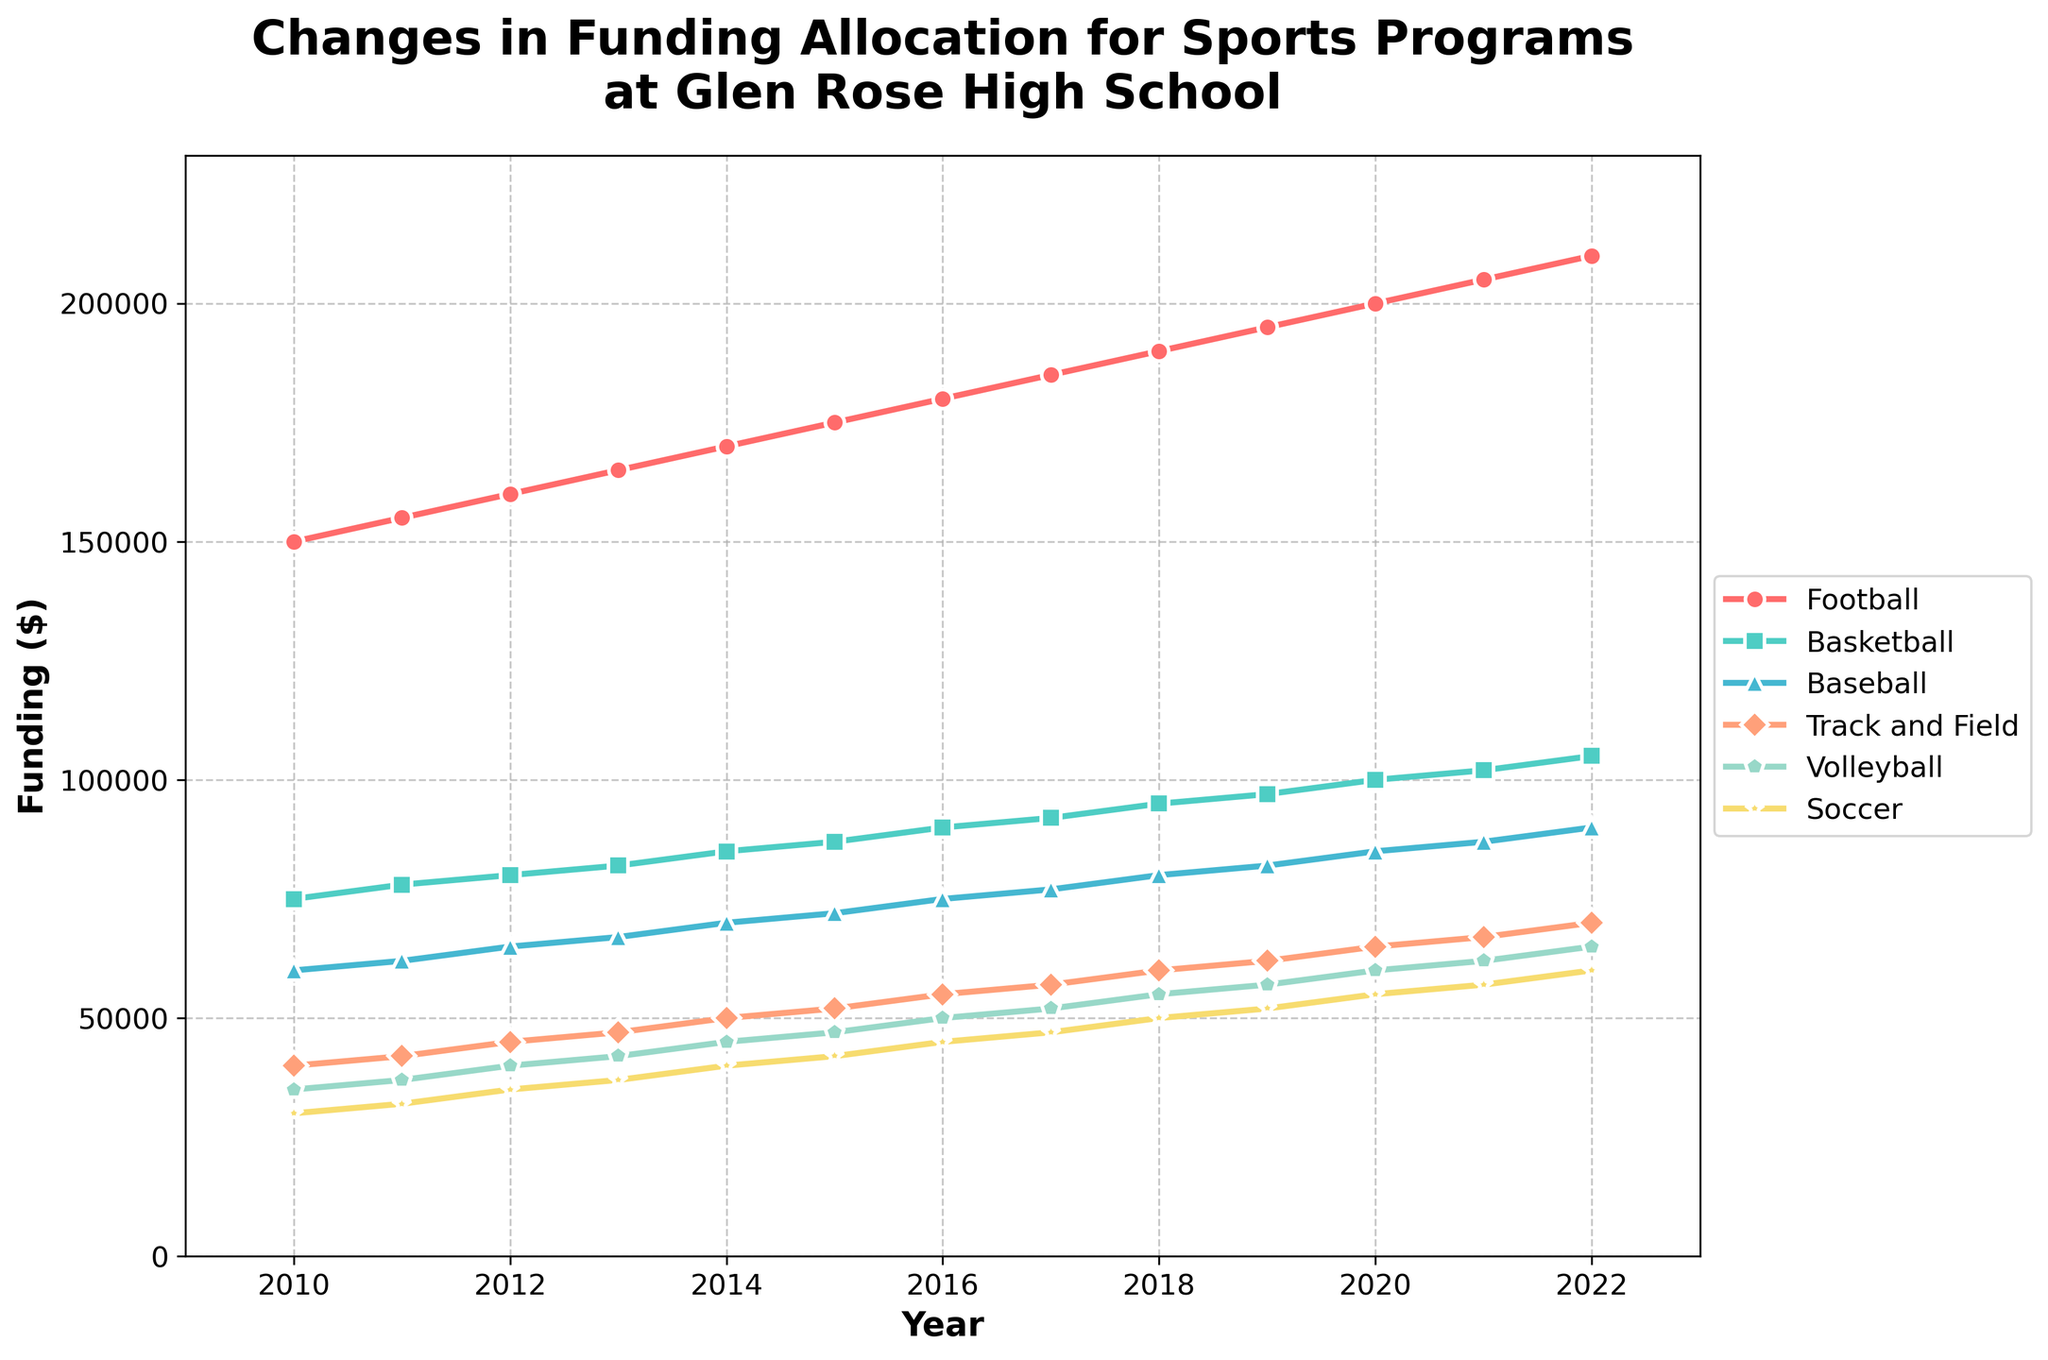How has the funding for the Football program changed from 2010 to 2022? The funding for the Football program in 2010 was $150,000, and it increased to $210,000 in 2022. The difference in funding is $210,000 - $150,000 = $60,000.
Answer: Increased by $60,000 Which sports program experienced the highest percent increase in funding from 2010 to 2022? To find the percent increase, use the formula: \( \frac{\text{New Value} - \text{Old Value}}{\text{Old Value}} \times 100 \). For each sport: 
Football: \( \frac{210000 - 150000}{150000} \times 100 = 40\% \) 
Basketball: \( \frac{105000 - 75000}{75000} \times 100 = 40\% \) 
Baseball: \( \frac{90000 - 60000}{60000} \times 100 = 50\% \) 
Track and Field: \( \frac{70000 - 40000}{40000} \times 100 = 75\% \) 
Volleyball: \( \frac{65000 - 35000}{35000} \times 100 = 85.71\% \) 
Soccer: \( \frac{60000 - 30000}{30000} \times 100 = 100\% \) Soccer experienced the highest percent increase in funding at 100%.
Answer: Soccer In which year did Basketball funding reach $90,000? The funding for Basketball reached $90,000 in the year 2016. This can be seen on the plot where the red line for Basketball crosses the $90,000 mark.
Answer: 2016 What is the average funding for the Soccer program from 2010 to 2022? Add up the funding amounts for Soccer from each year and divide by the number of years: \( \frac{30000 + 32000 + 35000 + 37000 + 40000 + 42000 + 45000 + 47000 + 50000 + 52000 + 55000 + 57000 + 60000}{13} = \frac{602000}{13} \approx 46307.69 \).
Answer: $46,308 Compare the funding for Baseball in 2015 to Volleyball in 2016. Which had higher funding? In 2015, the funding for Baseball was $72,000, and the funding for Volleyball in 2016 was $50,000. By comparing these amounts, we can see that Baseball had higher funding in 2015.
Answer: Baseball What is the total funding for Track and Field from 2010 to 2022? Add up the funding amounts for Track and Field from 2010 to 2022: \( 40000 + 42000 + 45000 + 47000 + 50000 + 52000 + 55000 + 57000 + 60000 + 62000 + 65000 + 67000 + 70000 = 732000 \).
Answer: $732,000 Which sport had the smallest increase in funding between 2010 and 2022? The smallest increase can be determined by finding the difference between the funding in 2022 and 2010 for each sport and identifying the smallest one:
Football: $210,000 - $150,000 = $60,000 
Basketball: $105,000 - $75,000 = $30,000 
Baseball: $90,000 - $60,000 = $30,000 
Track and Field: $70,000 - $40,000 = $30,000 
Volleyball: $65,000 - $35,000 = $30,000 
Soccer: $60,000 - $30,000 = $30,000. The sports with the smallest increase are Basketball, Baseball, Track and Field, Volleyball, and Soccer.
Answer: Basketball, Baseball, Track and Field, Volleyball, Soccer By how much did the funding for Track and Field change over the years 2015 to 2019? The funding for Track and Field in 2015 was $52,000, and it increased to $62,000 in 2019. The difference is $62,000 - $52,000 = $10,000.
Answer: $10,000 When did Volleyball's funding first exceed $50,000? To identify the year when Volleyball's funding exceeded $50,000, look for the first year the funding value crossed the $50,000 mark which happened in 2017.
Answer: 2017 Which sport consistently received the lowest funding across all the years? By observing the plots for each sport, Soccer consistently received the lowest funding across the years from 2010 to 2022.
Answer: Soccer 